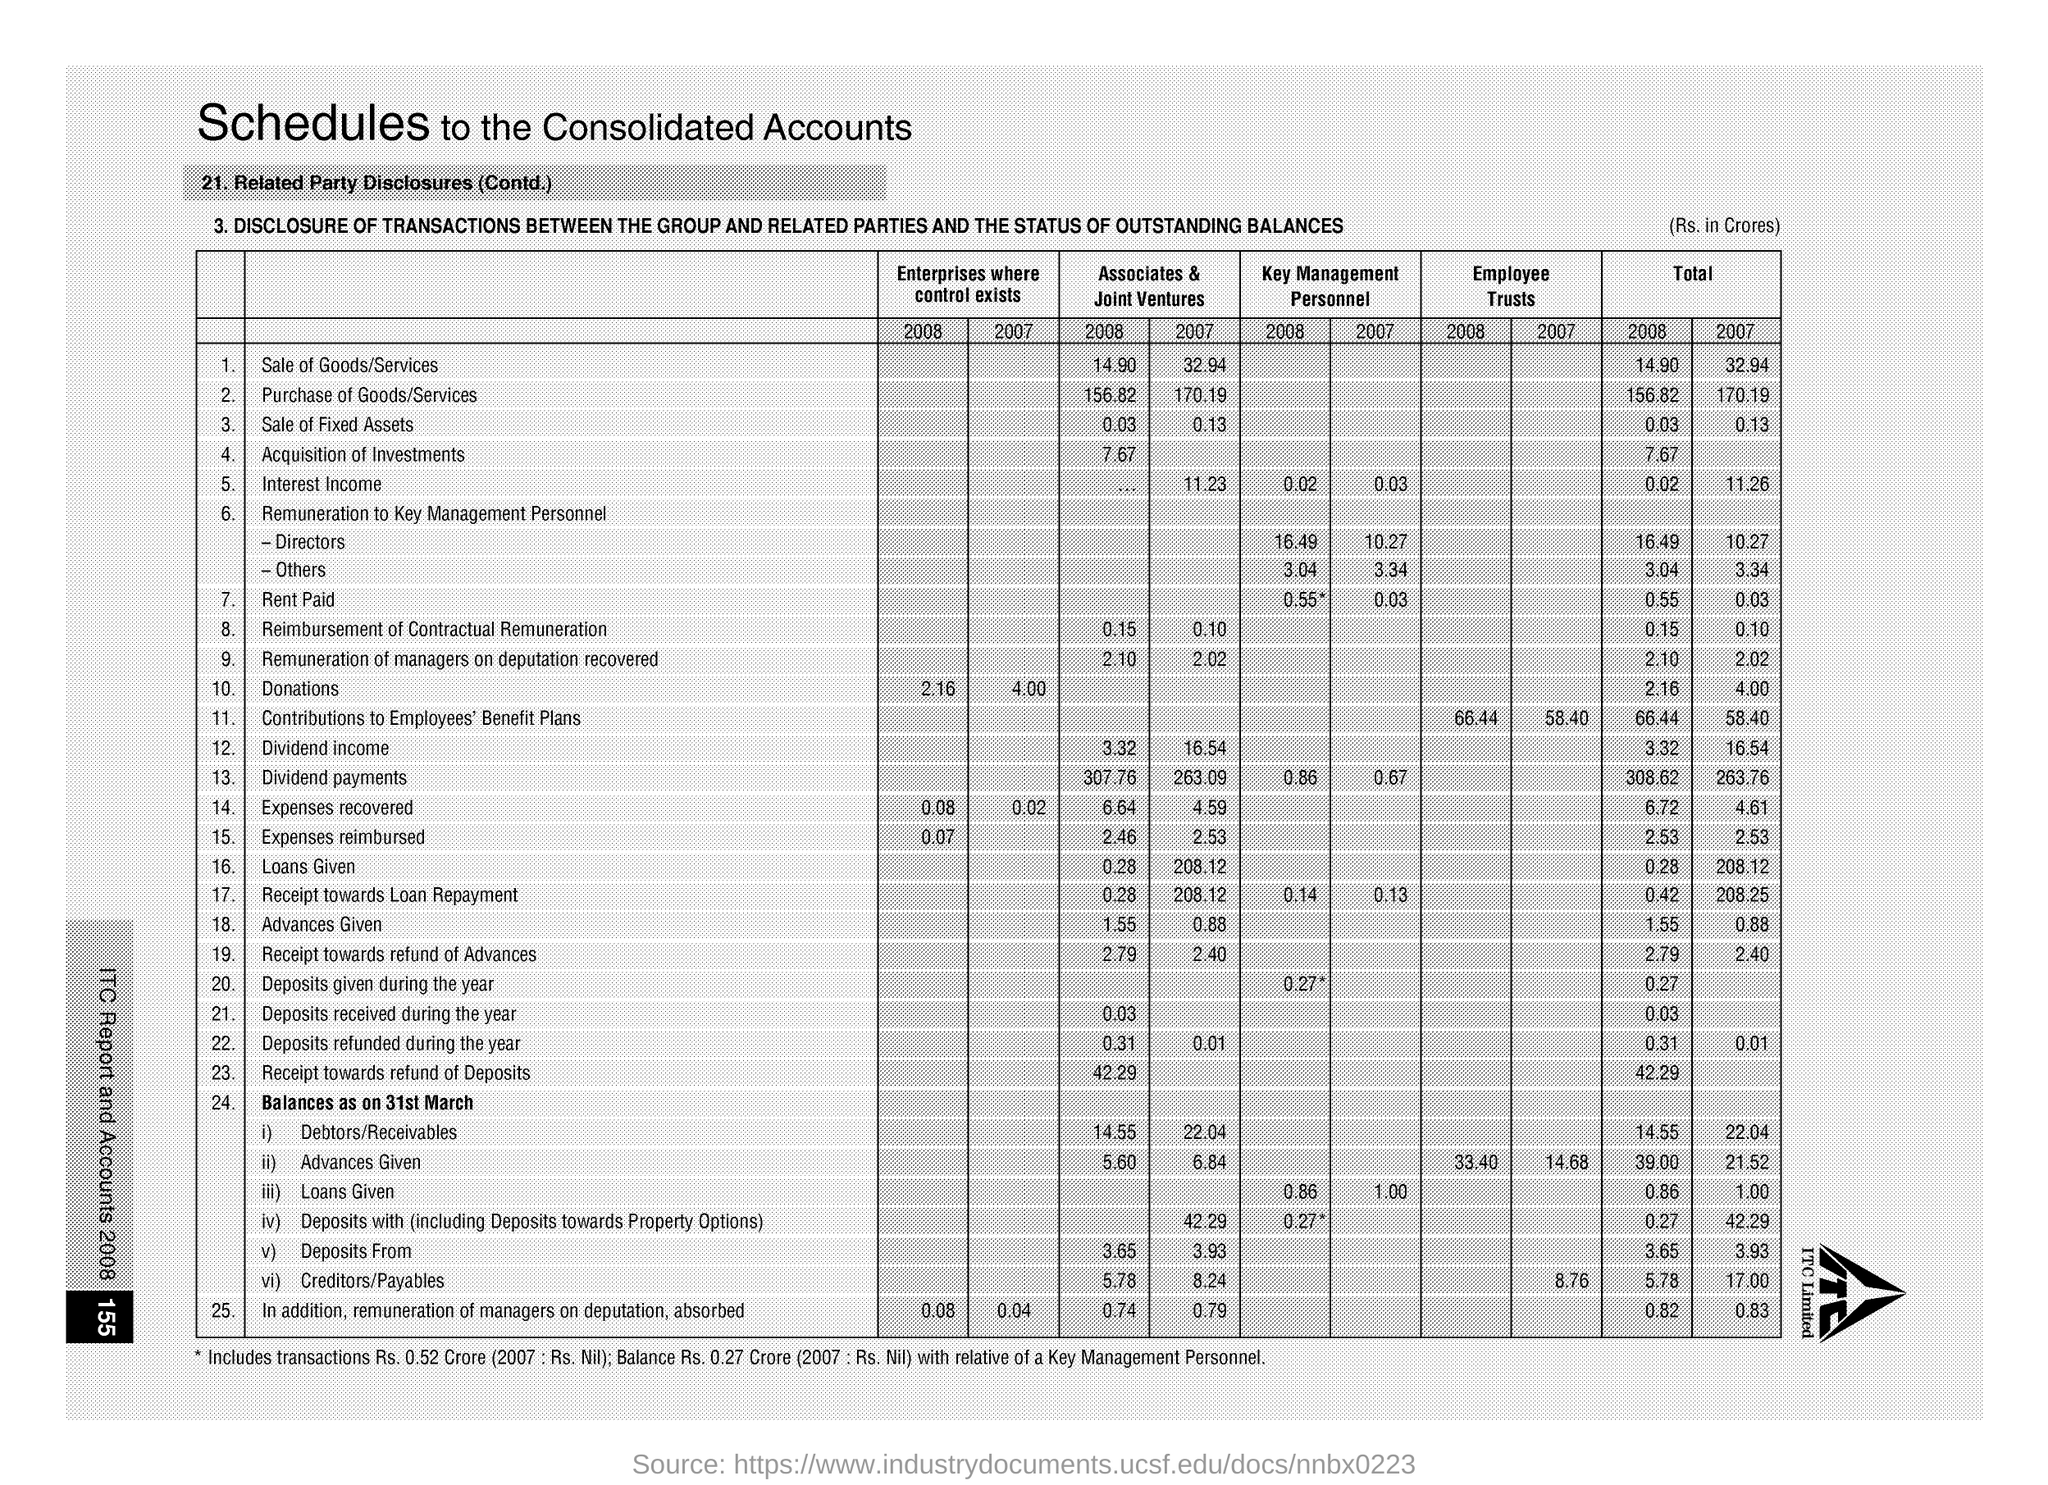Mention a couple of crucial points in this snapshot. In 2008, the total cost of purchasing goods and services was 156.82. The total for donations for 2007 is 4.00. The total amount of donations for the year 2008 is 2.16. The total amount spent for purchasing goods and services in 2007 was $170.19. The total for sale of goods/services for 2008 was 14.90. 